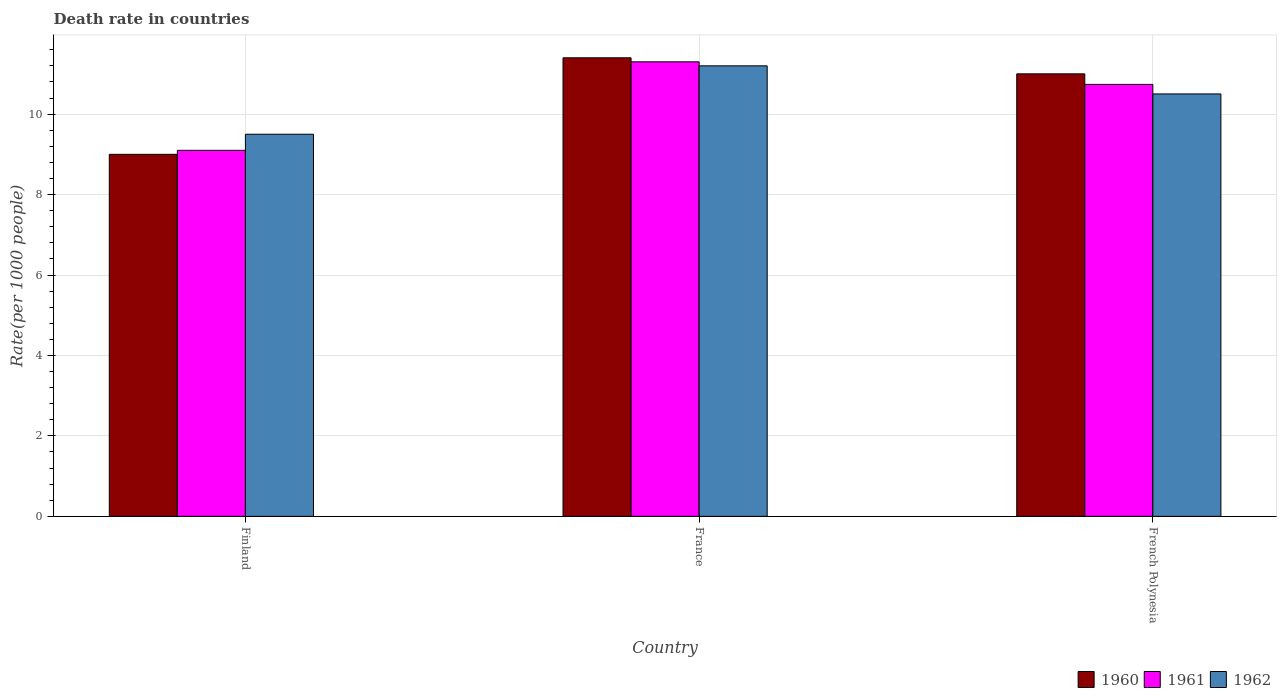How many different coloured bars are there?
Offer a very short reply. 3. Are the number of bars per tick equal to the number of legend labels?
Provide a succinct answer. Yes. Are the number of bars on each tick of the X-axis equal?
Your answer should be compact. Yes. How many bars are there on the 1st tick from the right?
Your answer should be very brief. 3. What is the label of the 1st group of bars from the left?
Make the answer very short. Finland. In how many cases, is the number of bars for a given country not equal to the number of legend labels?
Your answer should be very brief. 0. Across all countries, what is the maximum death rate in 1962?
Provide a short and direct response. 11.2. Across all countries, what is the minimum death rate in 1961?
Keep it short and to the point. 9.1. What is the total death rate in 1962 in the graph?
Your answer should be very brief. 31.2. What is the difference between the death rate in 1962 in Finland and that in French Polynesia?
Give a very brief answer. -1. What is the difference between the death rate in 1962 in Finland and the death rate in 1961 in France?
Offer a very short reply. -1.8. What is the average death rate in 1962 per country?
Offer a very short reply. 10.4. What is the difference between the death rate of/in 1960 and death rate of/in 1961 in French Polynesia?
Ensure brevity in your answer.  0.26. In how many countries, is the death rate in 1962 greater than 4.4?
Offer a very short reply. 3. What is the ratio of the death rate in 1961 in Finland to that in France?
Offer a terse response. 0.81. Is the death rate in 1960 in France less than that in French Polynesia?
Ensure brevity in your answer.  No. Is the difference between the death rate in 1960 in Finland and French Polynesia greater than the difference between the death rate in 1961 in Finland and French Polynesia?
Give a very brief answer. No. What is the difference between the highest and the second highest death rate in 1962?
Keep it short and to the point. -1. What is the difference between the highest and the lowest death rate in 1962?
Your answer should be very brief. 1.7. Is the sum of the death rate in 1960 in Finland and French Polynesia greater than the maximum death rate in 1961 across all countries?
Make the answer very short. Yes. What does the 2nd bar from the left in Finland represents?
Keep it short and to the point. 1961. How many bars are there?
Your answer should be very brief. 9. How many countries are there in the graph?
Provide a succinct answer. 3. What is the difference between two consecutive major ticks on the Y-axis?
Offer a terse response. 2. Are the values on the major ticks of Y-axis written in scientific E-notation?
Give a very brief answer. No. Where does the legend appear in the graph?
Offer a terse response. Bottom right. How many legend labels are there?
Offer a terse response. 3. What is the title of the graph?
Your response must be concise. Death rate in countries. Does "2007" appear as one of the legend labels in the graph?
Provide a succinct answer. No. What is the label or title of the Y-axis?
Your answer should be very brief. Rate(per 1000 people). What is the Rate(per 1000 people) in 1961 in Finland?
Provide a short and direct response. 9.1. What is the Rate(per 1000 people) in 1960 in France?
Your response must be concise. 11.4. What is the Rate(per 1000 people) of 1961 in France?
Offer a very short reply. 11.3. What is the Rate(per 1000 people) of 1960 in French Polynesia?
Keep it short and to the point. 11. What is the Rate(per 1000 people) of 1961 in French Polynesia?
Provide a succinct answer. 10.74. What is the Rate(per 1000 people) in 1962 in French Polynesia?
Give a very brief answer. 10.5. Across all countries, what is the maximum Rate(per 1000 people) of 1960?
Keep it short and to the point. 11.4. Across all countries, what is the minimum Rate(per 1000 people) of 1960?
Provide a short and direct response. 9. Across all countries, what is the minimum Rate(per 1000 people) in 1962?
Give a very brief answer. 9.5. What is the total Rate(per 1000 people) of 1960 in the graph?
Make the answer very short. 31.4. What is the total Rate(per 1000 people) of 1961 in the graph?
Offer a very short reply. 31.14. What is the total Rate(per 1000 people) in 1962 in the graph?
Give a very brief answer. 31.2. What is the difference between the Rate(per 1000 people) in 1960 in Finland and that in France?
Give a very brief answer. -2.4. What is the difference between the Rate(per 1000 people) in 1961 in Finland and that in France?
Offer a terse response. -2.2. What is the difference between the Rate(per 1000 people) in 1960 in Finland and that in French Polynesia?
Give a very brief answer. -2. What is the difference between the Rate(per 1000 people) of 1961 in Finland and that in French Polynesia?
Provide a succinct answer. -1.64. What is the difference between the Rate(per 1000 people) of 1962 in Finland and that in French Polynesia?
Offer a very short reply. -1. What is the difference between the Rate(per 1000 people) of 1960 in France and that in French Polynesia?
Give a very brief answer. 0.4. What is the difference between the Rate(per 1000 people) of 1961 in France and that in French Polynesia?
Provide a short and direct response. 0.56. What is the difference between the Rate(per 1000 people) in 1962 in France and that in French Polynesia?
Provide a succinct answer. 0.7. What is the difference between the Rate(per 1000 people) of 1960 in Finland and the Rate(per 1000 people) of 1961 in France?
Give a very brief answer. -2.3. What is the difference between the Rate(per 1000 people) in 1960 in Finland and the Rate(per 1000 people) in 1962 in France?
Provide a succinct answer. -2.2. What is the difference between the Rate(per 1000 people) of 1960 in Finland and the Rate(per 1000 people) of 1961 in French Polynesia?
Provide a succinct answer. -1.74. What is the difference between the Rate(per 1000 people) in 1960 in Finland and the Rate(per 1000 people) in 1962 in French Polynesia?
Ensure brevity in your answer.  -1.5. What is the difference between the Rate(per 1000 people) of 1961 in Finland and the Rate(per 1000 people) of 1962 in French Polynesia?
Your answer should be compact. -1.4. What is the difference between the Rate(per 1000 people) in 1960 in France and the Rate(per 1000 people) in 1961 in French Polynesia?
Keep it short and to the point. 0.66. What is the difference between the Rate(per 1000 people) of 1960 in France and the Rate(per 1000 people) of 1962 in French Polynesia?
Your answer should be compact. 0.9. What is the difference between the Rate(per 1000 people) of 1961 in France and the Rate(per 1000 people) of 1962 in French Polynesia?
Offer a very short reply. 0.8. What is the average Rate(per 1000 people) of 1960 per country?
Offer a terse response. 10.47. What is the average Rate(per 1000 people) in 1961 per country?
Offer a very short reply. 10.38. What is the average Rate(per 1000 people) of 1962 per country?
Your answer should be very brief. 10.4. What is the difference between the Rate(per 1000 people) of 1960 and Rate(per 1000 people) of 1961 in Finland?
Keep it short and to the point. -0.1. What is the difference between the Rate(per 1000 people) in 1960 and Rate(per 1000 people) in 1962 in Finland?
Offer a terse response. -0.5. What is the difference between the Rate(per 1000 people) of 1961 and Rate(per 1000 people) of 1962 in France?
Your answer should be very brief. 0.1. What is the difference between the Rate(per 1000 people) in 1960 and Rate(per 1000 people) in 1961 in French Polynesia?
Your response must be concise. 0.26. What is the difference between the Rate(per 1000 people) in 1960 and Rate(per 1000 people) in 1962 in French Polynesia?
Keep it short and to the point. 0.5. What is the difference between the Rate(per 1000 people) of 1961 and Rate(per 1000 people) of 1962 in French Polynesia?
Ensure brevity in your answer.  0.24. What is the ratio of the Rate(per 1000 people) of 1960 in Finland to that in France?
Provide a succinct answer. 0.79. What is the ratio of the Rate(per 1000 people) of 1961 in Finland to that in France?
Ensure brevity in your answer.  0.81. What is the ratio of the Rate(per 1000 people) in 1962 in Finland to that in France?
Make the answer very short. 0.85. What is the ratio of the Rate(per 1000 people) of 1960 in Finland to that in French Polynesia?
Provide a succinct answer. 0.82. What is the ratio of the Rate(per 1000 people) of 1961 in Finland to that in French Polynesia?
Provide a short and direct response. 0.85. What is the ratio of the Rate(per 1000 people) in 1962 in Finland to that in French Polynesia?
Ensure brevity in your answer.  0.9. What is the ratio of the Rate(per 1000 people) of 1960 in France to that in French Polynesia?
Give a very brief answer. 1.04. What is the ratio of the Rate(per 1000 people) of 1961 in France to that in French Polynesia?
Ensure brevity in your answer.  1.05. What is the ratio of the Rate(per 1000 people) in 1962 in France to that in French Polynesia?
Your answer should be compact. 1.07. What is the difference between the highest and the second highest Rate(per 1000 people) of 1960?
Make the answer very short. 0.4. What is the difference between the highest and the second highest Rate(per 1000 people) of 1961?
Your answer should be compact. 0.56. What is the difference between the highest and the second highest Rate(per 1000 people) of 1962?
Keep it short and to the point. 0.7. What is the difference between the highest and the lowest Rate(per 1000 people) in 1960?
Make the answer very short. 2.4. 